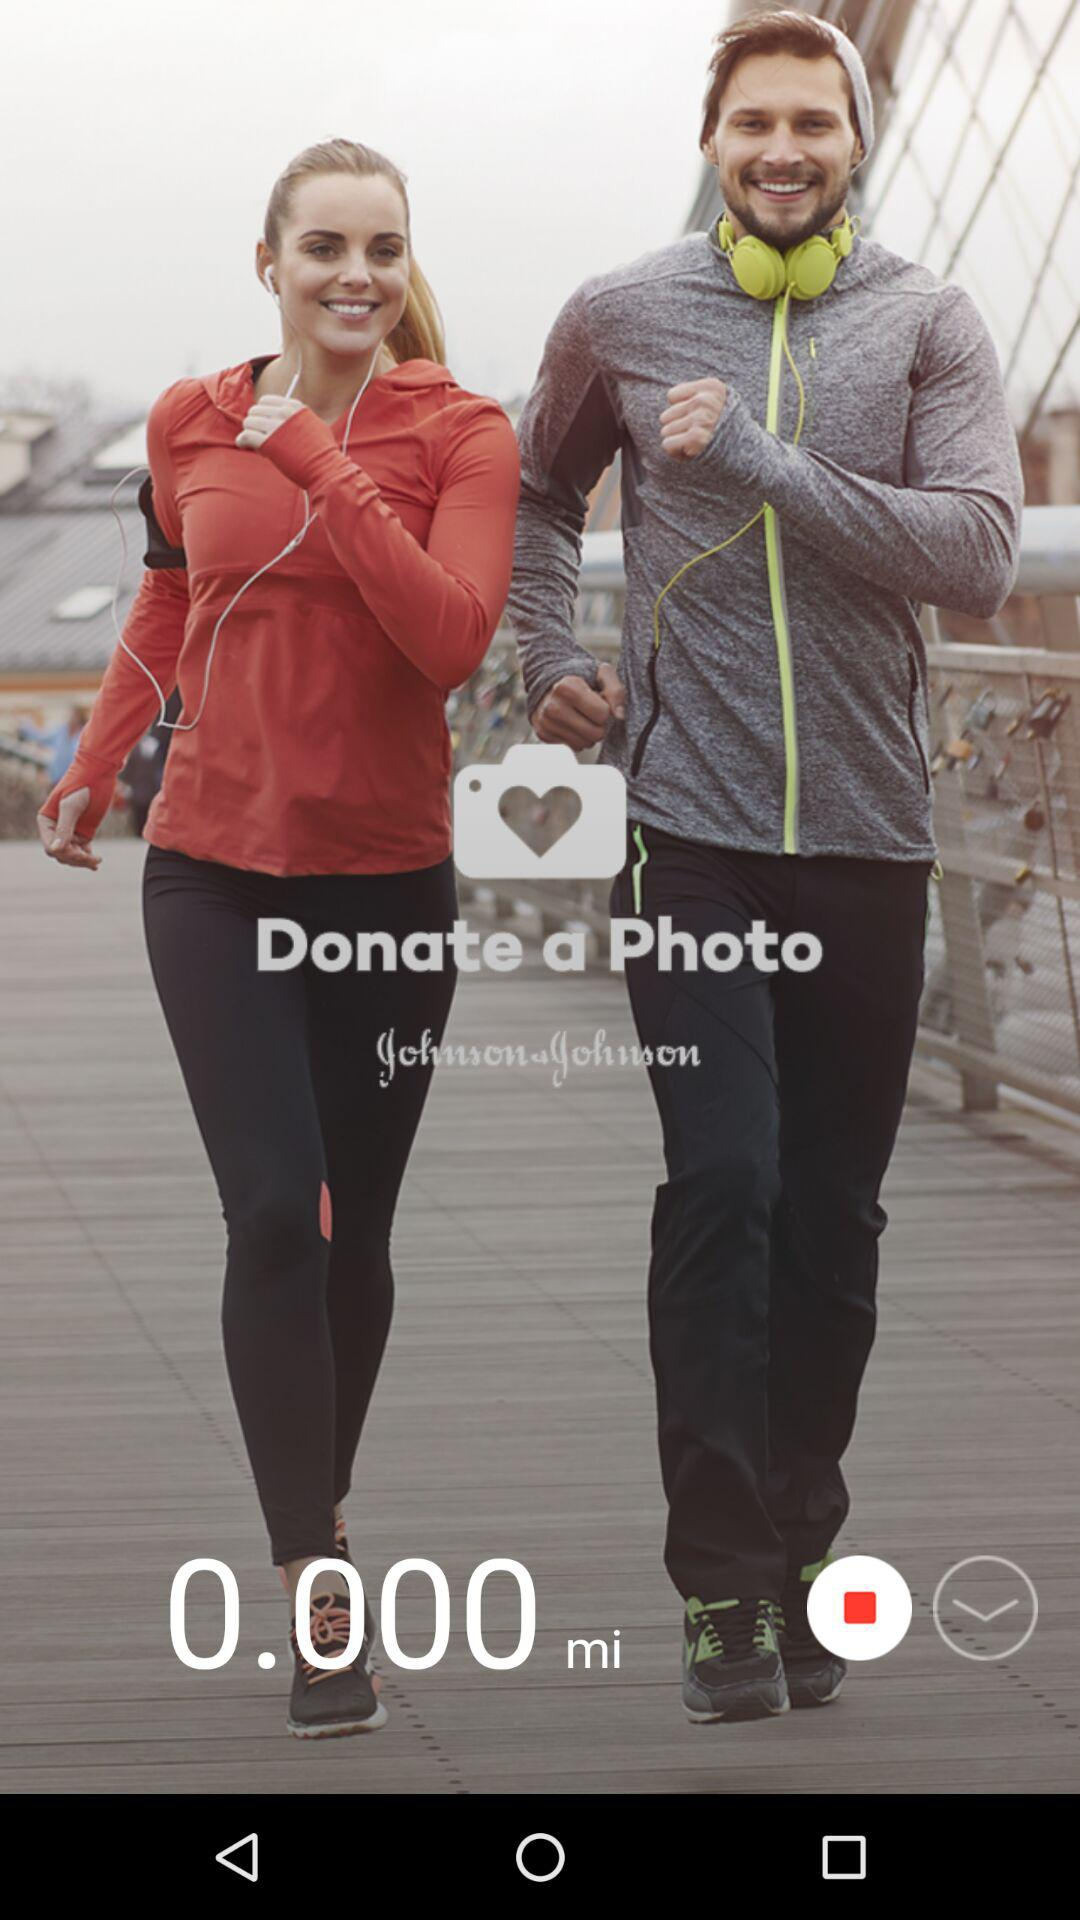What is the name of the application? The name of the application is "Donate a Photo". 